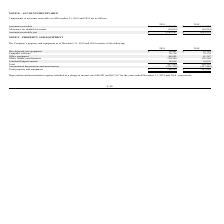From Telkonet's financial document, What are the types of property and equipment? The document contains multiple relevant values: development test equipment, computer software, office equipment, office fixtures and furniture, leasehold improvements. From the document: "Office equipment 66,685 61,367 Development test equipment $ 16,461 $ 19,110 Leasehold improvements 18,016 18,016 Computer software 76,134 76,134 Offic..." Also, What is the total property and equipment for the year ended December 31, 2019? According to the financial document, 186,525. The relevant text states: "Total property and equipment $ 186,525 $ 247,289..." Also, What is the depreciation and amortization expenses for the year ended December 31, 2019? According to the financial document, $66,082. The relevant text states: "ization expense included as a charge to income was $66,082 and $67,107 for the years ended December 31, 2019 and 2018, respectively...." Additionally, Which year has a higher total value of property and equipment? According to the financial document, 2018. The relevant text states: "f accounts receivable as of December 31, 2019 and 2018 are as follows: 2019 2018..." Also, can you calculate: What is the percentage change in the value of computer software from 2018 to 2019? I cannot find a specific answer to this question in the financial document. Also, can you calculate: What is the percentage change in the Depreciation and amortization expense from 2018 to 2019? To answer this question, I need to perform calculations using the financial data. The calculation is: (66,082-67,107)/67,107, which equals -1.53 (percentage). This is based on the information: "e included as a charge to income was $66,082 and $67,107 for the years ended December 31, 2019 and 2018, respectively. ation expense included as a charge to income was $66,082 and $67,107 for the year..." The key data points involved are: 66,082, 67,107. 